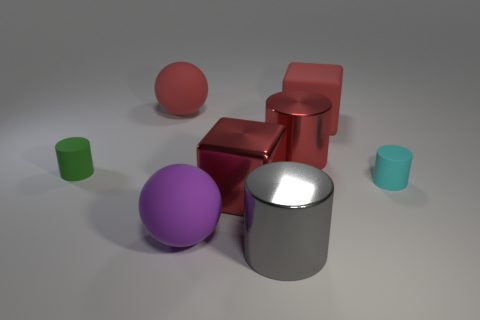Add 1 red objects. How many objects exist? 9 Subtract all blocks. How many objects are left? 6 Add 6 balls. How many balls exist? 8 Subtract 0 blue cylinders. How many objects are left? 8 Subtract all big gray things. Subtract all small green cylinders. How many objects are left? 6 Add 2 metallic cylinders. How many metallic cylinders are left? 4 